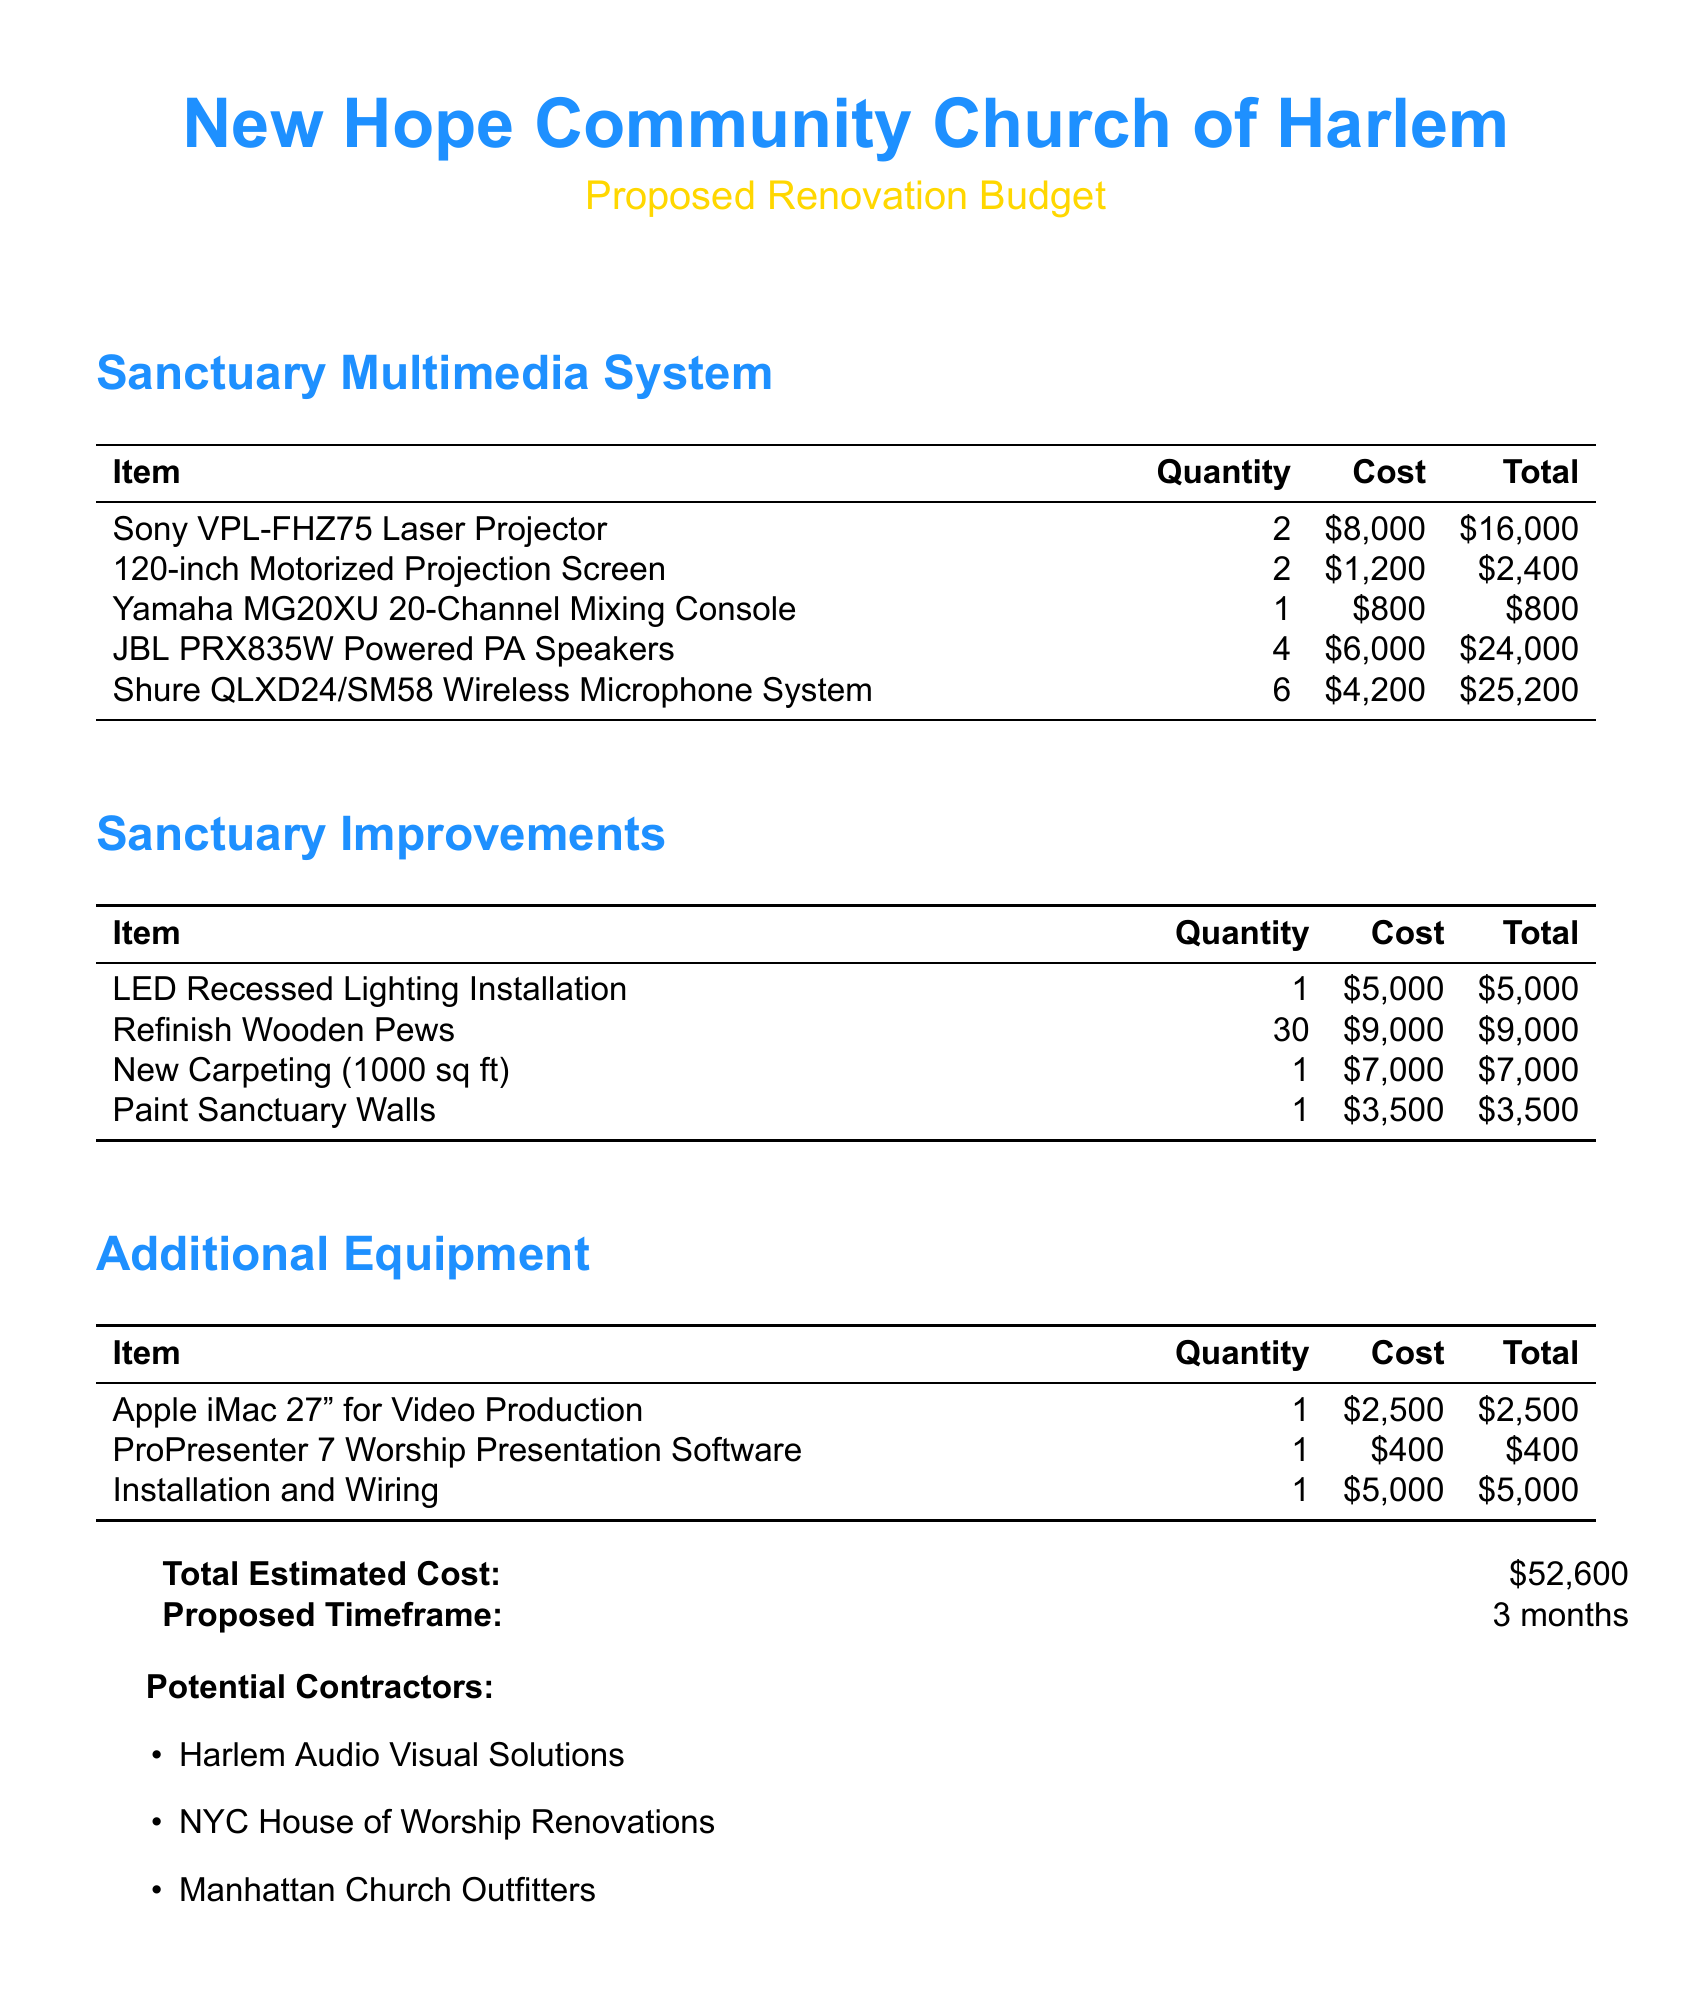What is the total estimated cost? The total estimated cost is provided at the end of the document, which sums all the individual costs outlined in the budget.
Answer: $52,600 How many JBL PRX835W speakers are included? The quantity of JBL PRX835W speakers is listed in the multimedia system section of the budget.
Answer: 4 What is the cost of refinishing the wooden pews? The cost for refinishing the wooden pews can be found in the sanctuary improvements section of the document.
Answer: $9,000 What software is proposed for worship presentations? The software for worship presentations is specified in the additional equipment section of the document.
Answer: ProPresenter 7 Worship Presentation Software What is the proposed timeframe for the renovations? The proposed timeframe is mentioned in the document, summarizing the duration expected for the project.
Answer: 3 months How many wireless microphone systems are included? The number of Shure QLXD24/SM58 Wireless Microphone Systems can be found in the multimedia system section.
Answer: 6 What type of lighting installation is planned? The type of lighting installation is listed under sanctuary improvements in the document.
Answer: LED Recessed Lighting Installation Who is one potential contractor mentioned? A list of potential contractors is provided at the end of the document; any one from the list can be a valid answer.
Answer: Harlem Audio Visual Solutions 